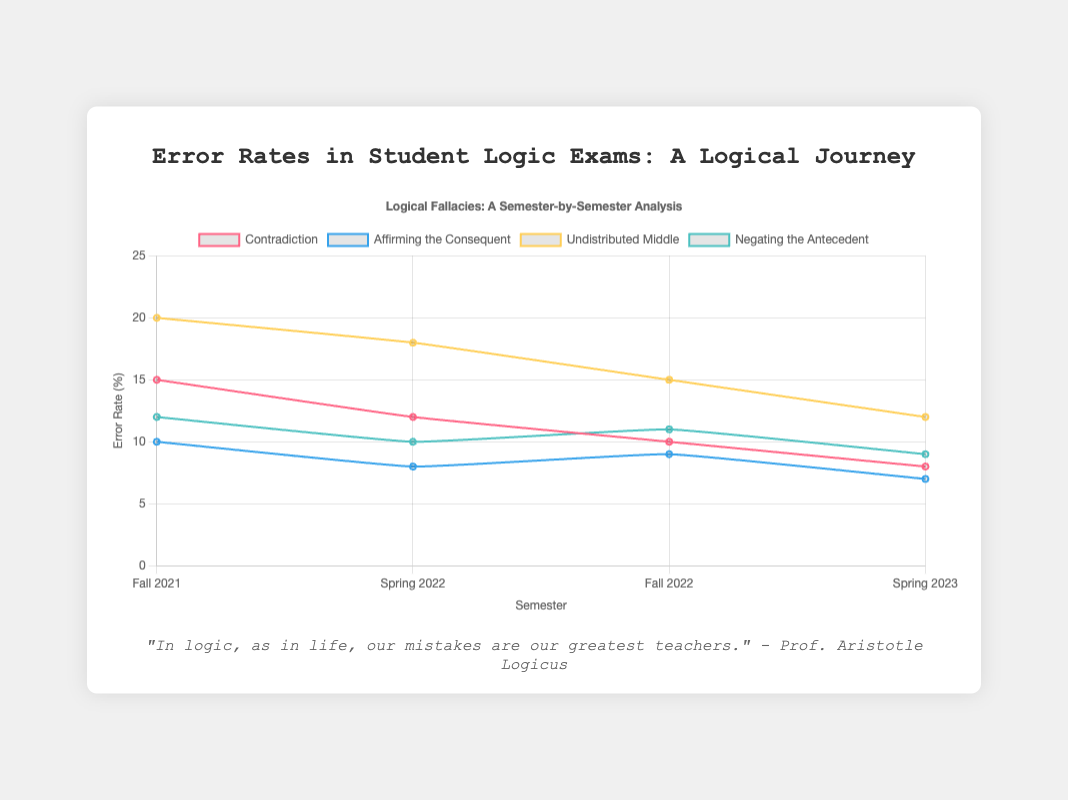What's the general trend of error rates for the "Contradiction" type over the semesters? The error rates for "Contradiction" start at 15% in Fall 2021, then decrease to 12% in Spring 2022, further decrease to 10% in Fall 2022, and finally drop to 8% in Spring 2023. This indicates a downward trend in error rates.
Answer: Downward trend Which type of error saw the greatest decrease in error rates from Fall 2021 to Spring 2023? Subtract the error rates in Spring 2023 from those in Fall 2021 for each error type: Contradiction (15-8 = 7%), Affirming the Consequent (10-7 = 3%), Undistributed Middle (20-12 = 8%), and Negating the Antecedent (12-9 = 3%). "Undistributed Middle" saw the greatest decrease of 8%.
Answer: Undistributed Middle Which error type has the highest error rate in Fall 2022? Look at the error rates in Fall 2022 for all error types: Contradiction (10%), Affirming the Consequent (9%), Undistributed Middle (15%), and Negating the Antecedent (11%). "Undistributed Middle" has the highest error rate at 15%.
Answer: Undistributed Middle Compare the error rates of "Affirming the Consequent" and "Negating the Antecedent" in Spring 2023. Which is lower? Look at the error rates in Spring 2023: Affirming the Consequent (7%) and Negating the Antecedent (9%). "Affirming the Consequent" has a lower error rate at 7%.
Answer: Affirming the Consequent Calculate the average error rate for "Undistributed Middle" over the four semesters. Sum the error rates for "Undistributed Middle" for all semesters: 20% + 18% + 15% + 12% = 65%. Divide by 4 semesters: 65% / 4 = 16.25%.
Answer: 16.25% Are the error rates for "Negating the Antecedent" steadily decreasing over the semesters? The error rates for "Negating the Antecedent" are 12% in Fall 2021, then decrease to 10% in Spring 2022, slightly increase to 11% in Fall 2022, and finally decrease to 9% in Spring 2023. There is not a steady decrease due to the increase in Fall 2022.
Answer: No 